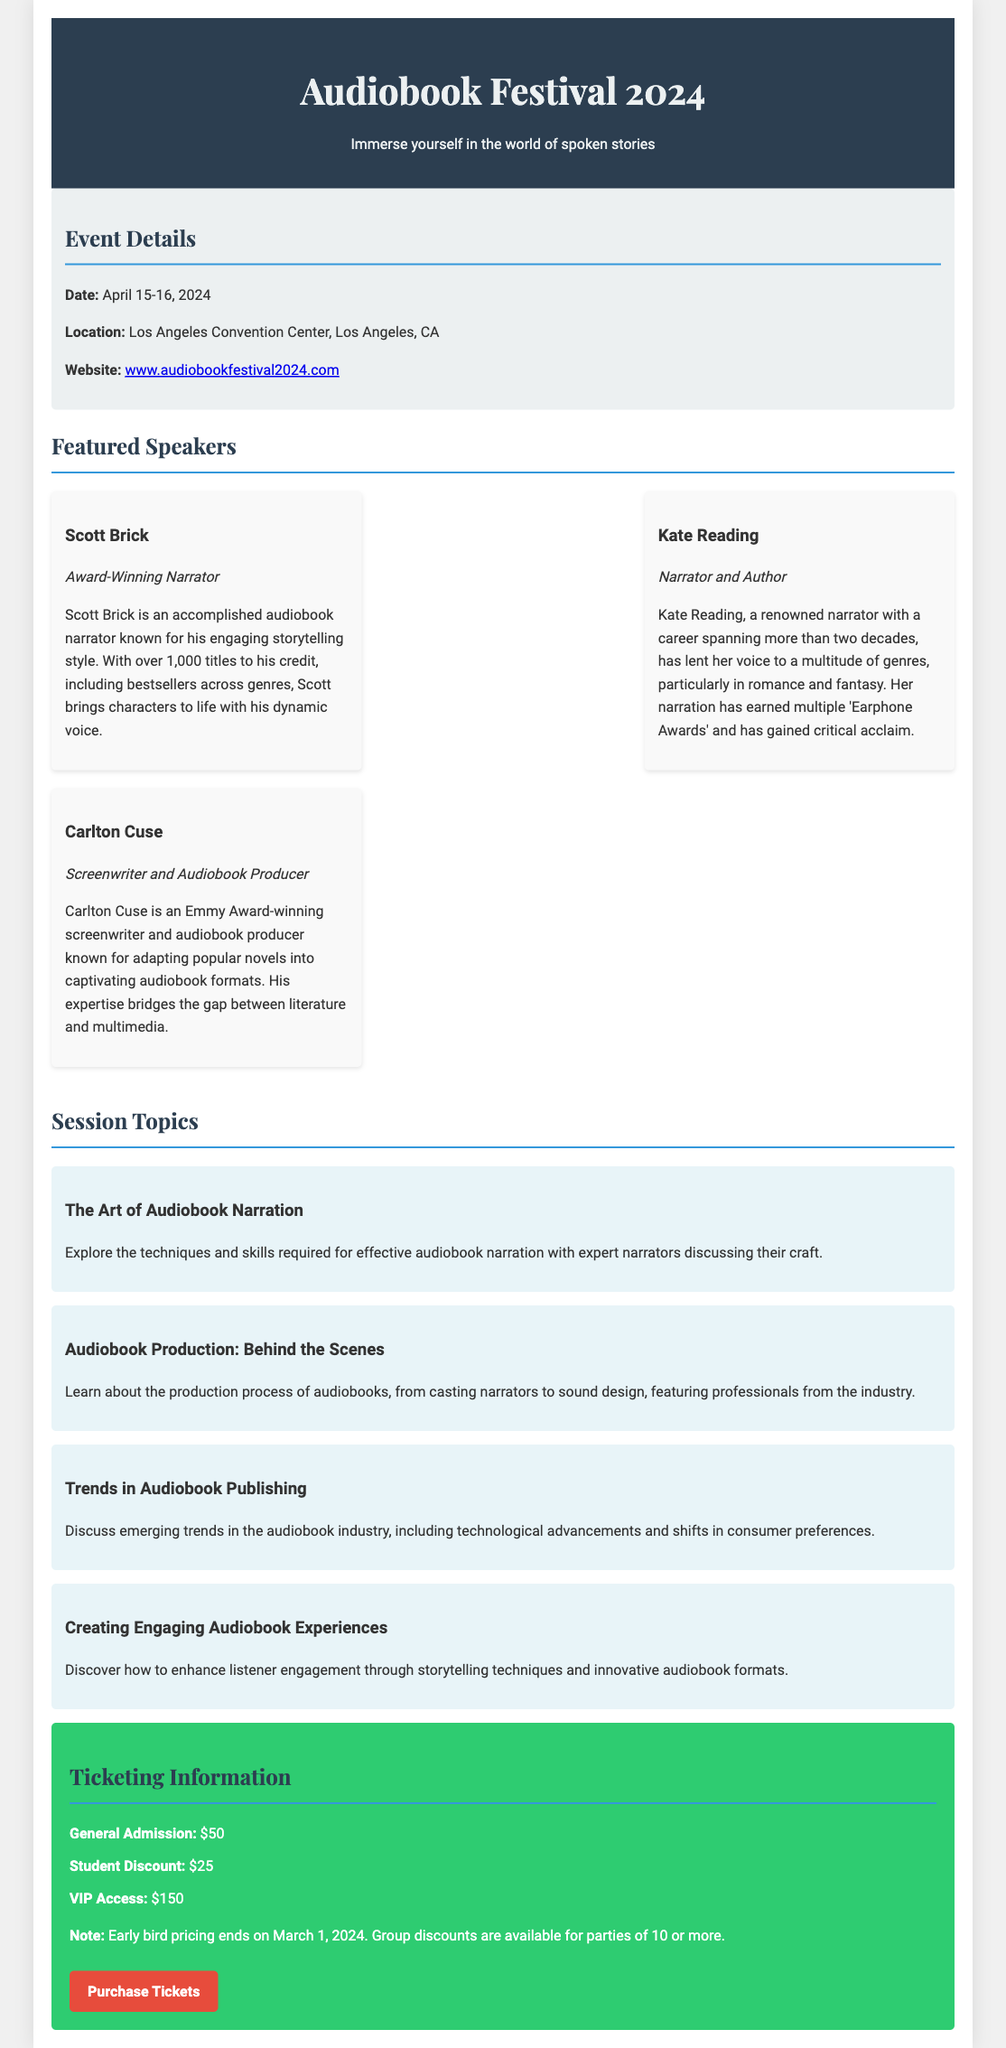What are the event dates? The event dates are specified in the document as April 15-16, 2024.
Answer: April 15-16, 2024 Where is the Audiobook Festival 2024 taking place? The location of the festival is given as Los Angeles Convention Center, Los Angeles, CA.
Answer: Los Angeles Convention Center, Los Angeles, CA Who is an award-winning narrator featured at the festival? The document highlights Scott Brick as an award-winning narrator.
Answer: Scott Brick What is the general admission ticket price? The price for a general admission ticket is stated in the ticketing section.
Answer: $50 What is the last date for early bird pricing? The document mentions that early bird pricing ends on March 1, 2024.
Answer: March 1, 2024 Which topic covers narration techniques? The session focused on this aspect is titled "The Art of Audiobook Narration."
Answer: The Art of Audiobook Narration What type of discount is available for students? The document specifies a student discount mentioned under ticketing information.
Answer: $25 How many featured speakers are listed? The number of speakers mentioned in the promotional one-sheet is three: Scott Brick, Kate Reading, and Carlton Cuse.
Answer: Three 